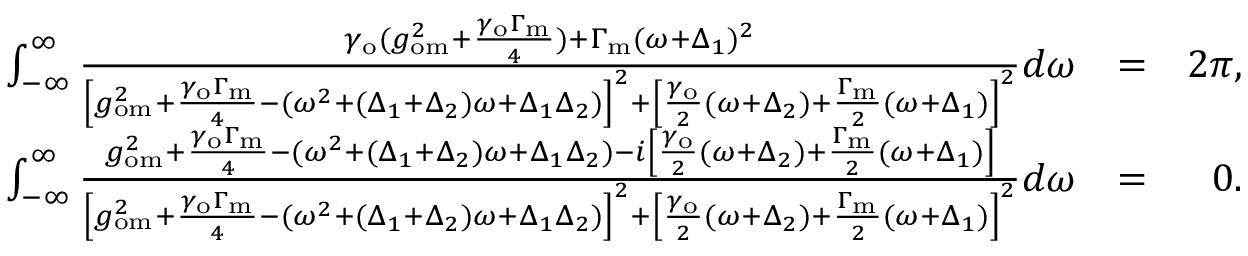Convert formula to latex. <formula><loc_0><loc_0><loc_500><loc_500>\begin{array} { r l r } { \int _ { - \infty } ^ { \infty } \frac { \gamma _ { o } ( g _ { o m } ^ { 2 } + \frac { \gamma _ { o } \Gamma _ { m } } { 4 } ) + \Gamma _ { m } ( \omega + \Delta _ { 1 } ) ^ { 2 } } { \left [ g _ { o m } ^ { 2 } + \frac { \gamma _ { o } \Gamma _ { m } } { 4 } - ( \omega ^ { 2 } + ( \Delta _ { 1 } + \Delta _ { 2 } ) \omega + \Delta _ { 1 } \Delta _ { 2 } ) \right ] ^ { 2 } + \left [ \frac { \gamma _ { o } } { 2 } ( \omega + \Delta _ { 2 } ) + \frac { \Gamma _ { m } } { 2 } ( \omega + \Delta _ { 1 } ) \right ] ^ { 2 } } d \omega } & { = } & { 2 \pi , } \\ { \int _ { - \infty } ^ { \infty } \frac { g _ { o m } ^ { 2 } + \frac { \gamma _ { o } \Gamma _ { m } } { 4 } - ( \omega ^ { 2 } + ( \Delta _ { 1 } + \Delta _ { 2 } ) \omega + \Delta _ { 1 } \Delta _ { 2 } ) - i \left [ \frac { \gamma _ { o } } { 2 } ( \omega + \Delta _ { 2 } ) + \frac { \Gamma _ { m } } { 2 } ( \omega + \Delta _ { 1 } ) \right ] } { \left [ g _ { o m } ^ { 2 } + \frac { \gamma _ { o } \Gamma _ { m } } { 4 } - ( \omega ^ { 2 } + ( \Delta _ { 1 } + \Delta _ { 2 } ) \omega + \Delta _ { 1 } \Delta _ { 2 } ) \right ] ^ { 2 } + \left [ \frac { \gamma _ { o } } { 2 } ( \omega + \Delta _ { 2 } ) + \frac { \Gamma _ { m } } { 2 } ( \omega + \Delta _ { 1 } ) \right ] ^ { 2 } } d \omega } & { = } & { 0 . } \end{array}</formula> 